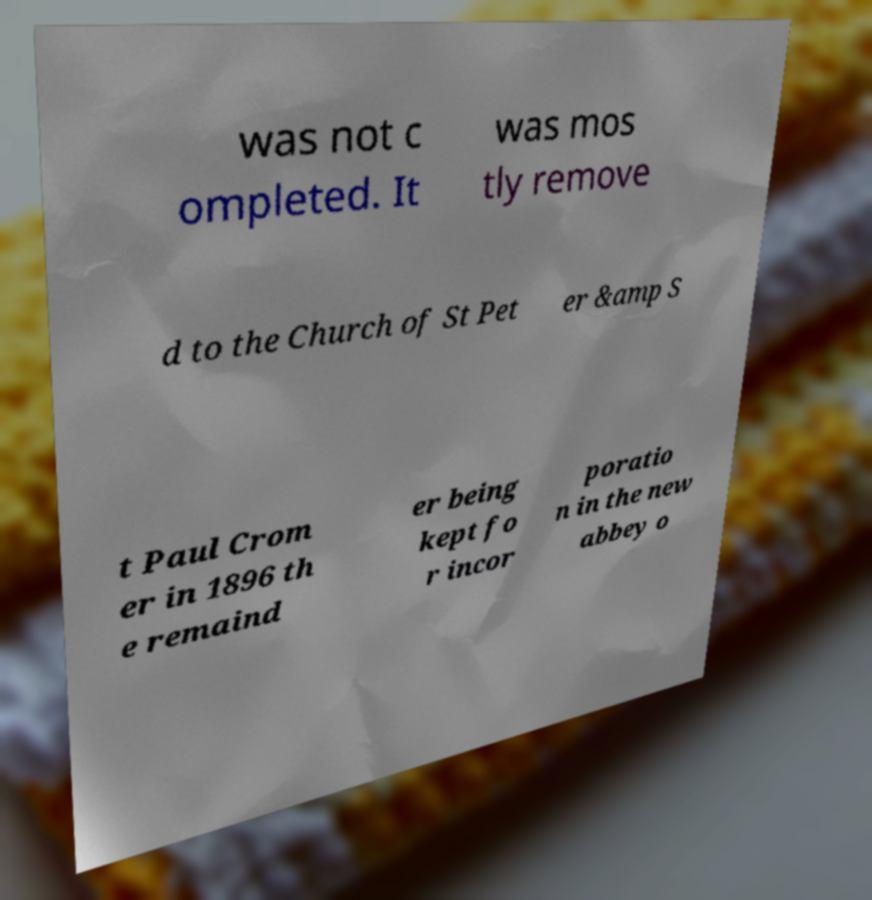Could you extract and type out the text from this image? was not c ompleted. It was mos tly remove d to the Church of St Pet er &amp S t Paul Crom er in 1896 th e remaind er being kept fo r incor poratio n in the new abbey o 